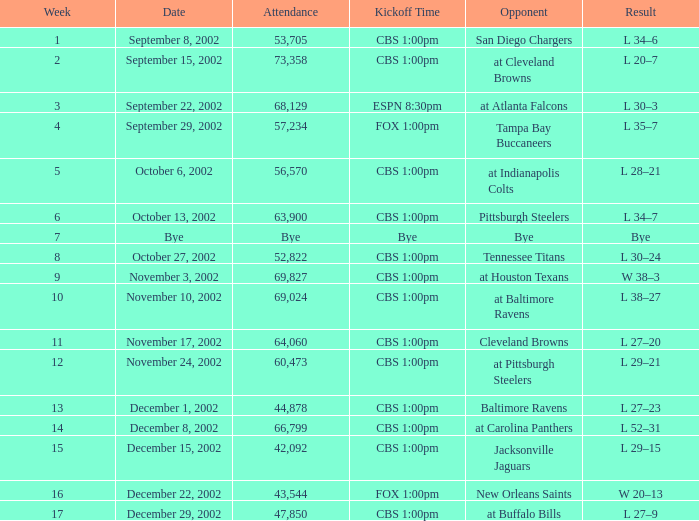What is the result of the game with 57,234 people in attendance? L 35–7. 